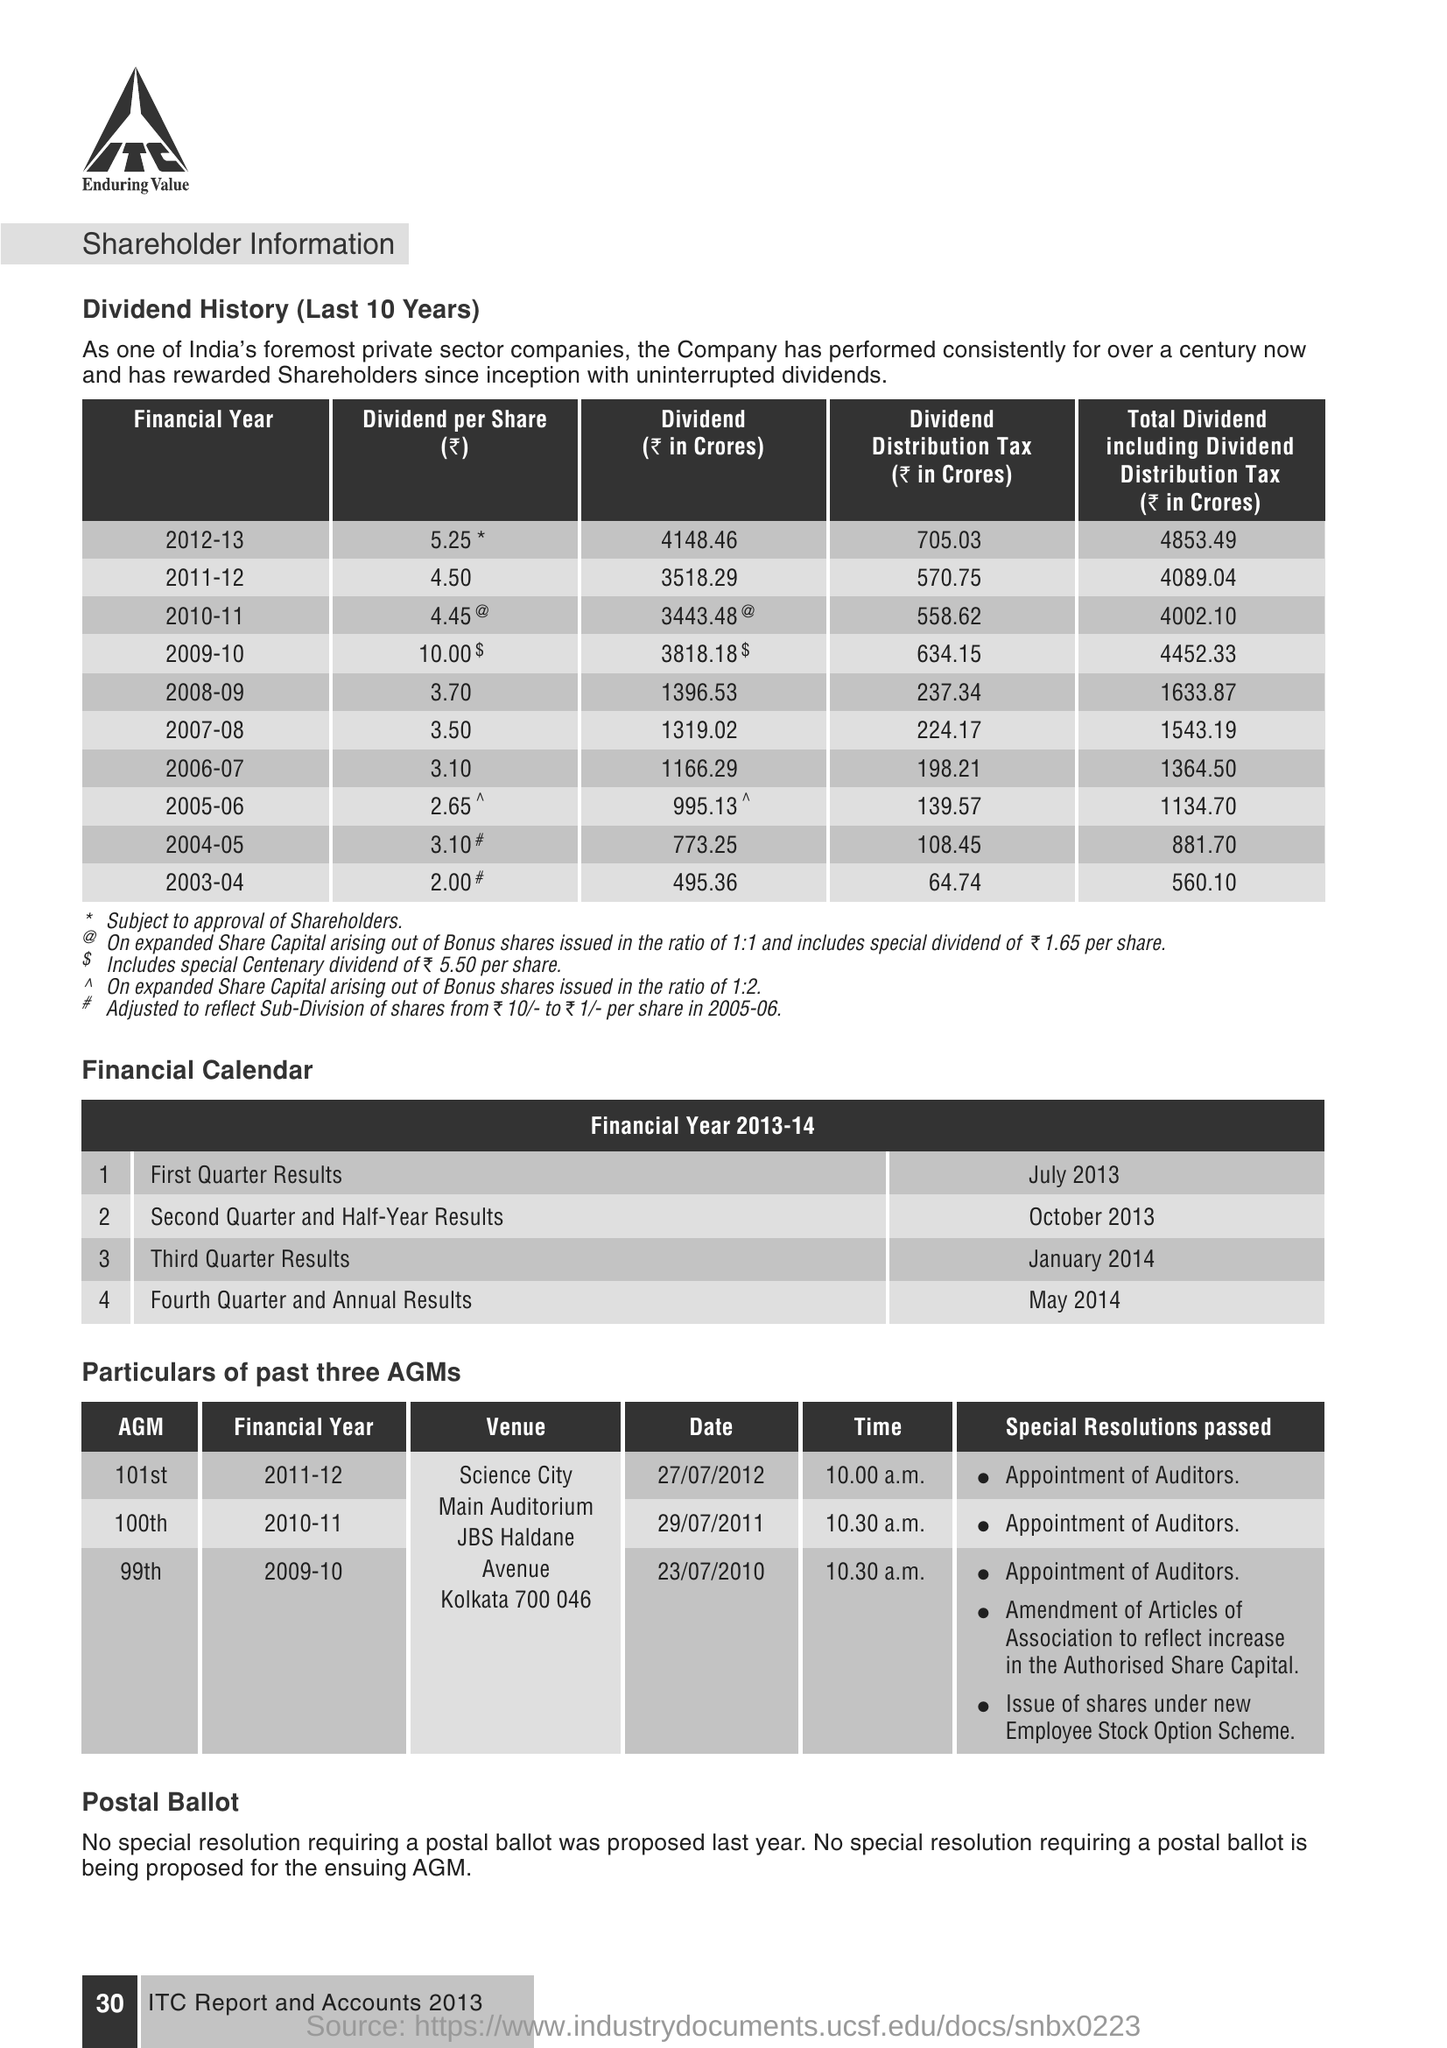on which date the 101st AGM was conducted? The 101st Annual General Meeting (AGM) of the company was conducted on July 27, 2012, at Science City, Main Auditorium, JBS Haldane Avenue, Kolkata 700 046. 